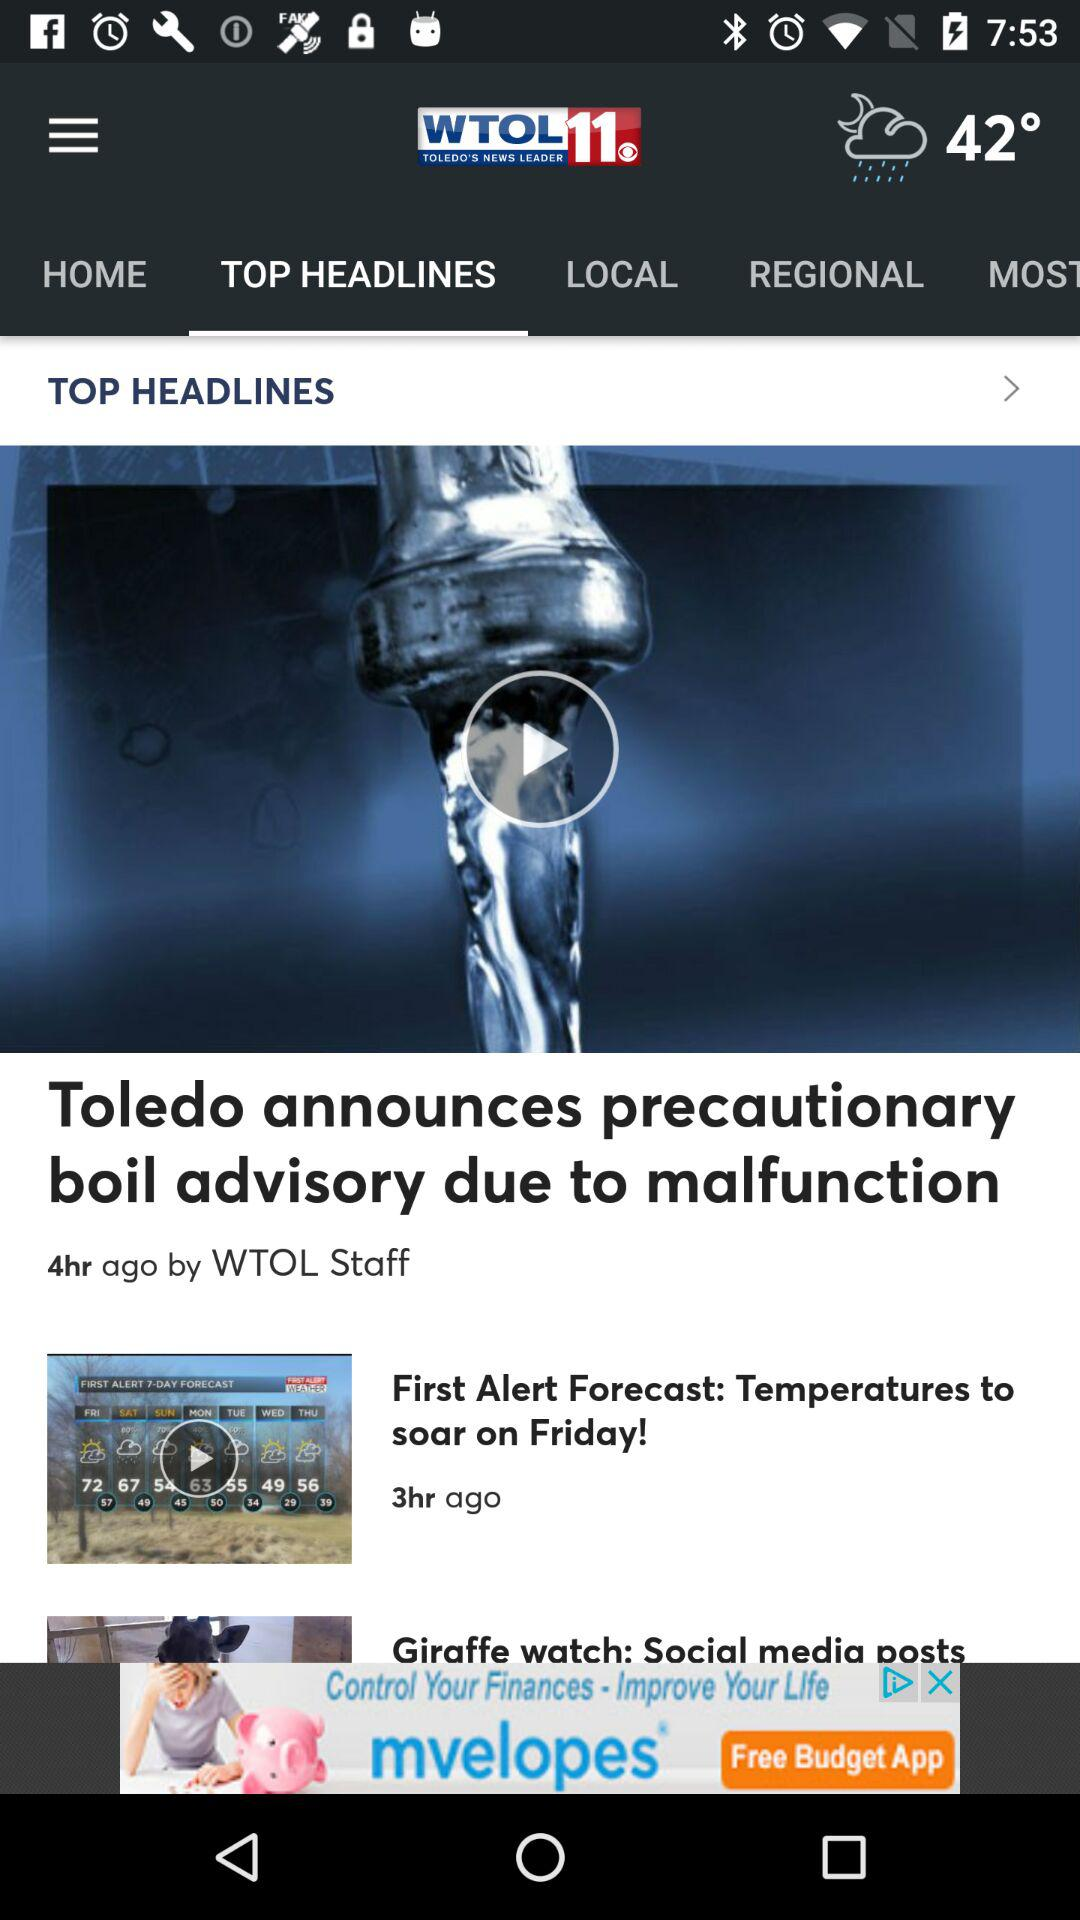How many hours ago was the article about the faucet published?
Answer the question using a single word or phrase. 4 